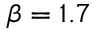<formula> <loc_0><loc_0><loc_500><loc_500>\beta = 1 . 7</formula> 